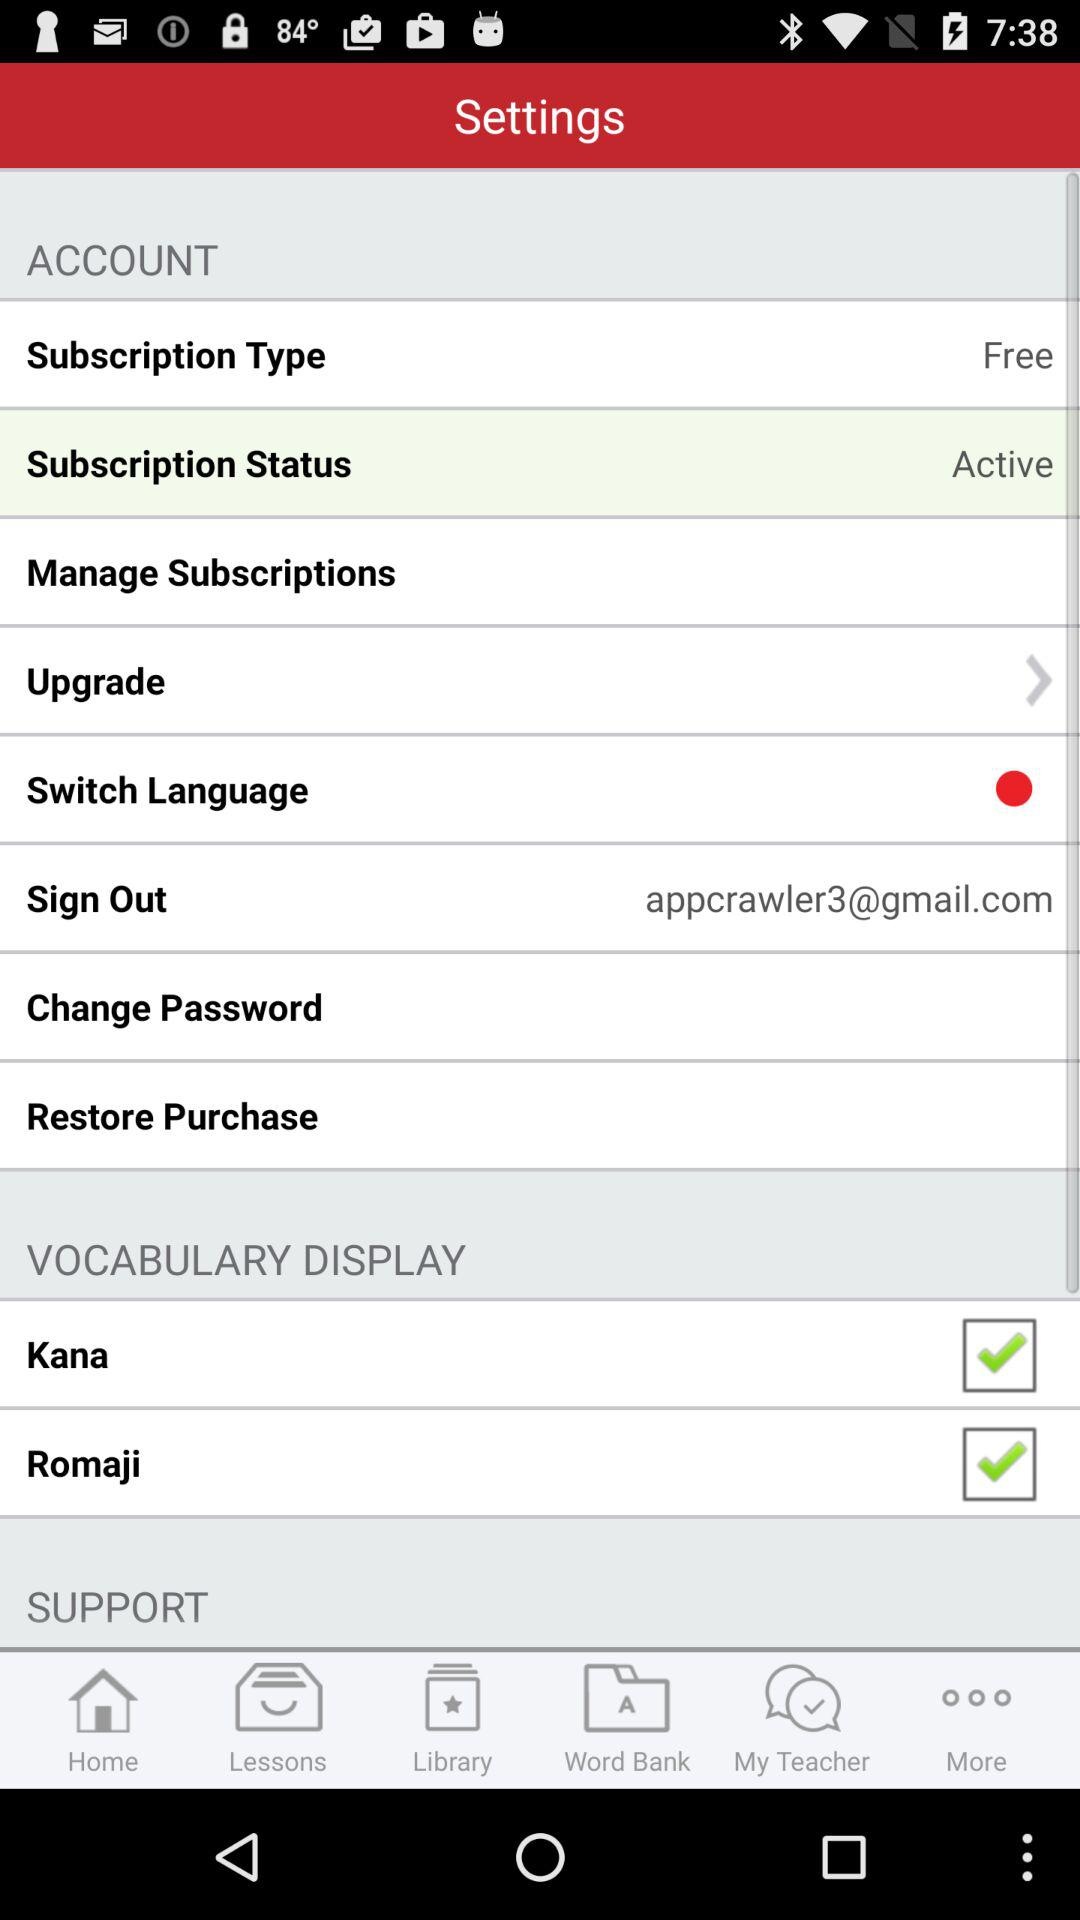What is the subscription type? The subscription type is free. 